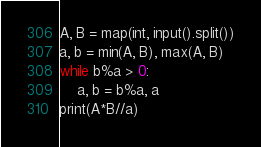Convert code to text. <code><loc_0><loc_0><loc_500><loc_500><_Python_>A, B = map(int, input().split())
a, b = min(A, B), max(A, B)
while b%a > 0:
    a, b = b%a, a
print(A*B//a)
</code> 